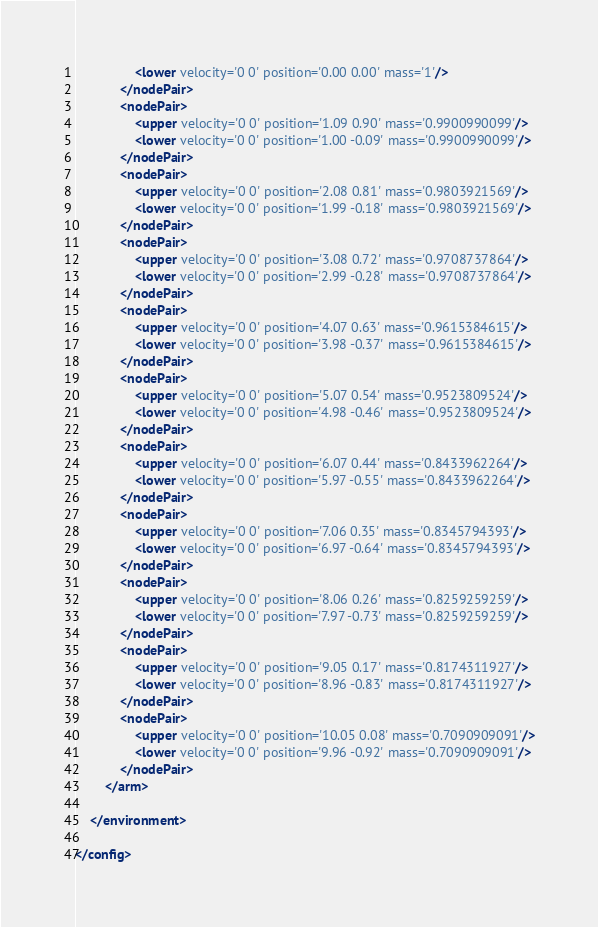Convert code to text. <code><loc_0><loc_0><loc_500><loc_500><_XML_>                <lower velocity='0 0' position='0.00 0.00' mass='1'/>
            </nodePair>
            <nodePair>
                <upper velocity='0 0' position='1.09 0.90' mass='0.9900990099'/>
                <lower velocity='0 0' position='1.00 -0.09' mass='0.9900990099'/>
            </nodePair>
            <nodePair>
                <upper velocity='0 0' position='2.08 0.81' mass='0.9803921569'/>
                <lower velocity='0 0' position='1.99 -0.18' mass='0.9803921569'/>
            </nodePair>
            <nodePair>
                <upper velocity='0 0' position='3.08 0.72' mass='0.9708737864'/>
                <lower velocity='0 0' position='2.99 -0.28' mass='0.9708737864'/>
            </nodePair>
            <nodePair>
                <upper velocity='0 0' position='4.07 0.63' mass='0.9615384615'/>
                <lower velocity='0 0' position='3.98 -0.37' mass='0.9615384615'/>
            </nodePair>
            <nodePair>
                <upper velocity='0 0' position='5.07 0.54' mass='0.9523809524'/>
                <lower velocity='0 0' position='4.98 -0.46' mass='0.9523809524'/>
            </nodePair>
            <nodePair>
                <upper velocity='0 0' position='6.07 0.44' mass='0.8433962264'/>
                <lower velocity='0 0' position='5.97 -0.55' mass='0.8433962264'/>
            </nodePair>
            <nodePair>
                <upper velocity='0 0' position='7.06 0.35' mass='0.8345794393'/>
                <lower velocity='0 0' position='6.97 -0.64' mass='0.8345794393'/>
            </nodePair>
            <nodePair>
                <upper velocity='0 0' position='8.06 0.26' mass='0.8259259259'/>
                <lower velocity='0 0' position='7.97 -0.73' mass='0.8259259259'/>
            </nodePair>
            <nodePair>
                <upper velocity='0 0' position='9.05 0.17' mass='0.8174311927'/>
                <lower velocity='0 0' position='8.96 -0.83' mass='0.8174311927'/>
            </nodePair>
            <nodePair>
                <upper velocity='0 0' position='10.05 0.08' mass='0.7090909091'/>
                <lower velocity='0 0' position='9.96 -0.92' mass='0.7090909091'/>
            </nodePair>
        </arm>

    </environment>

</config>
</code> 